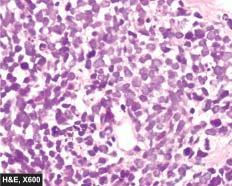what are arranged in sheets, cords or aggregates and at places form pseudorosettes?
Answer the question using a single word or phrase. Tumour cells 